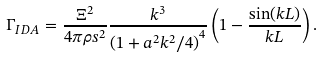<formula> <loc_0><loc_0><loc_500><loc_500>\Gamma _ { I D A } = \frac { \Xi ^ { 2 } } { 4 \pi \rho s ^ { 2 } } \frac { k ^ { 3 } } { \left ( 1 + a ^ { 2 } k ^ { 2 } / 4 \right ) ^ { 4 } } \left ( 1 - \frac { \sin ( k L ) } { k L } \right ) .</formula> 